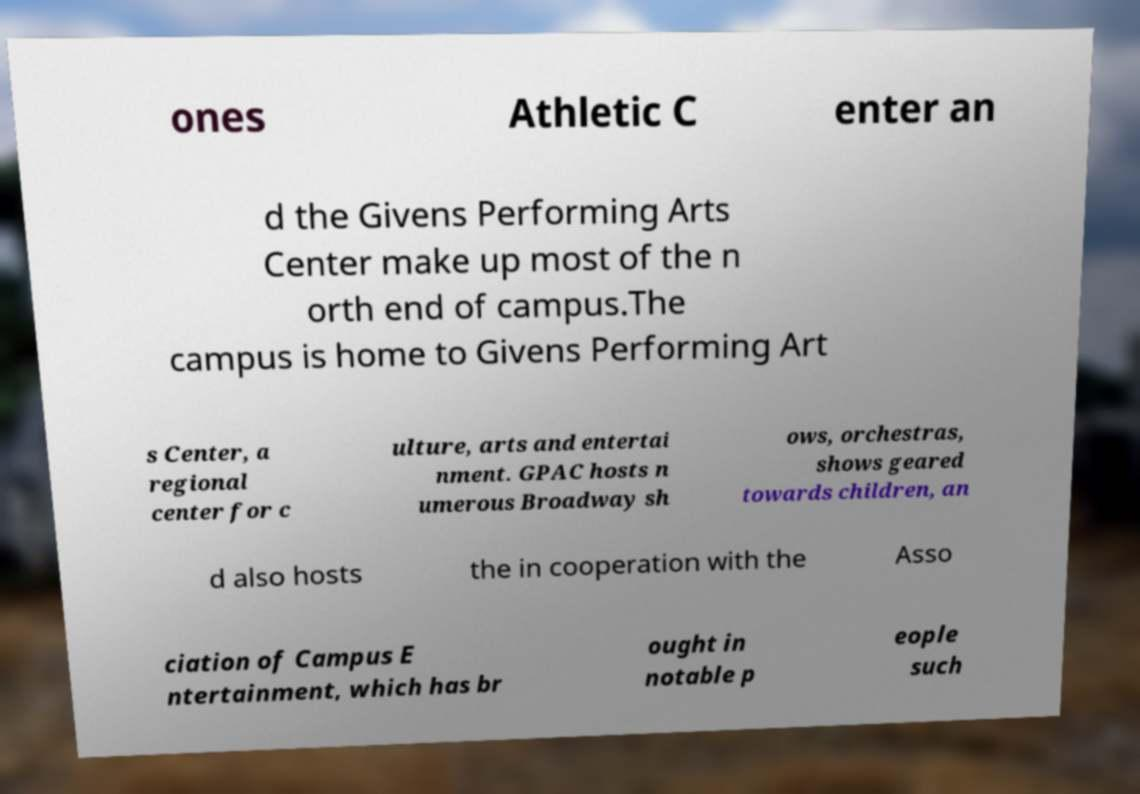I need the written content from this picture converted into text. Can you do that? ones Athletic C enter an d the Givens Performing Arts Center make up most of the n orth end of campus.The campus is home to Givens Performing Art s Center, a regional center for c ulture, arts and entertai nment. GPAC hosts n umerous Broadway sh ows, orchestras, shows geared towards children, an d also hosts the in cooperation with the Asso ciation of Campus E ntertainment, which has br ought in notable p eople such 